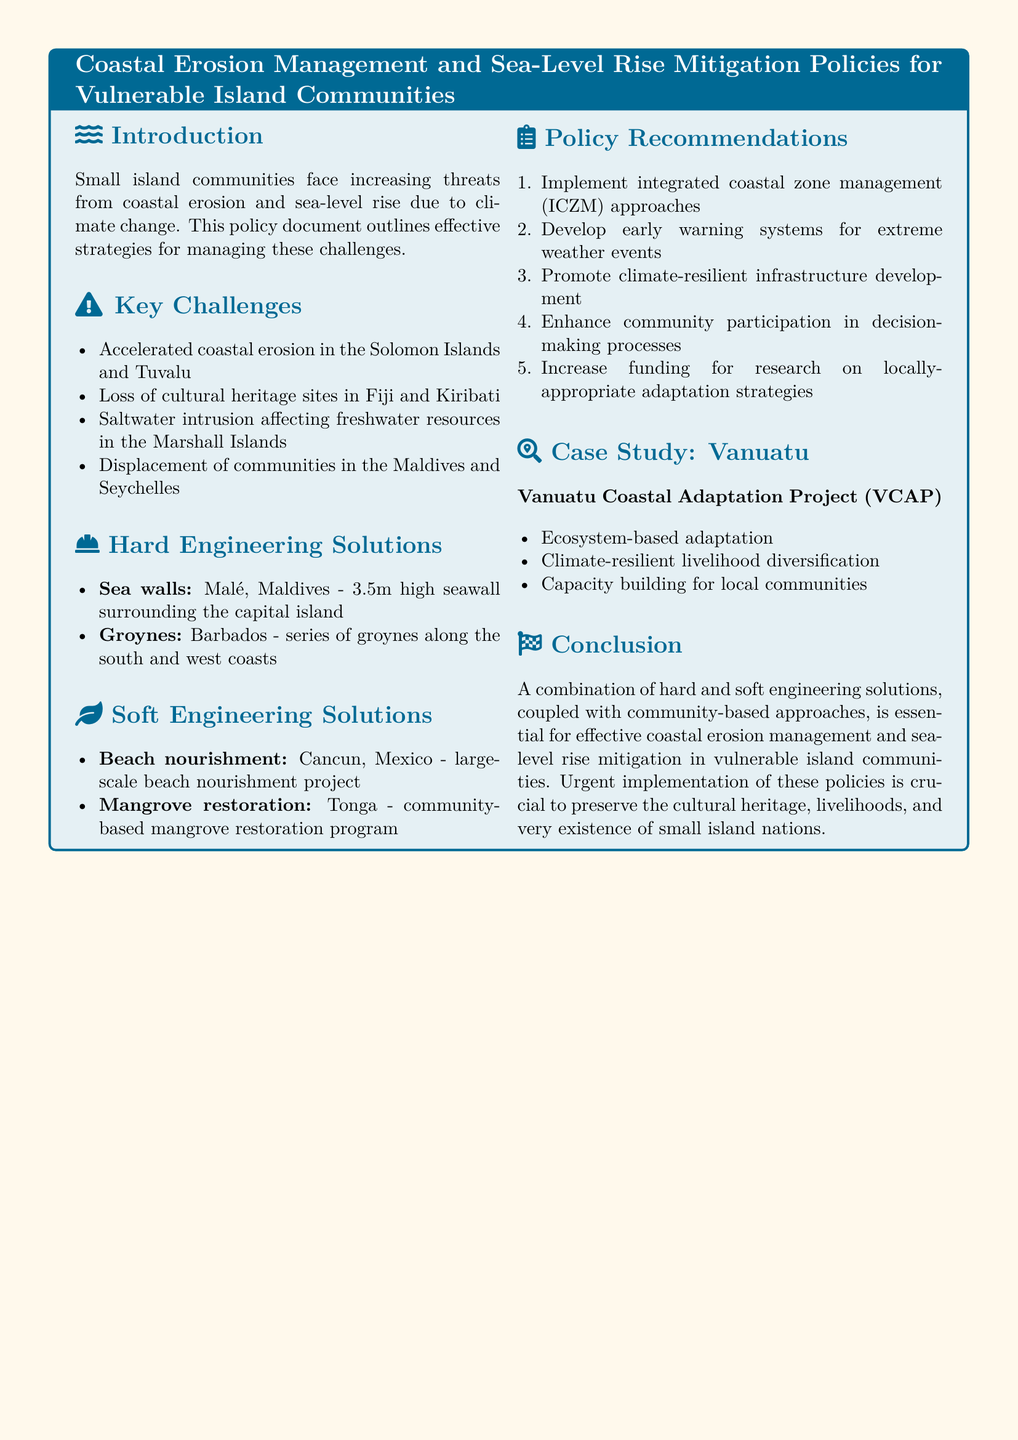What is the title of the document? The title of the document is found at the top section of the rendered policy document.
Answer: Coastal Erosion Management and Sea-Level Rise Mitigation Policies for Vulnerable Island Communities What is one key challenge mentioned regarding Fiji? The document lists challenges related to various island nations, including Fiji.
Answer: Loss of cultural heritage sites What hard engineering solution is implemented in the Maldives? The document outlines specific hard engineering solutions used in various locations, including the Maldives.
Answer: Sea walls What soft engineering solution is practiced in Tonga? The document mentions certain soft engineering solutions utilized in Tonga.
Answer: Mangrove restoration What is one policy recommendation provided in the document? The document includes a list of policy recommendations for managing coastal erosion and sea-level rise.
Answer: Implement integrated coastal zone management (ICZM) approaches What is one aim of the Vanuatu Coastal Adaptation Project? The case study section includes objectives for the Vanuatu Coastal Adaptation Project.
Answer: Ecosystem-based adaptation How many meters high is the seawall in Malé? The document provides specific measurements for the seawall mentioned.
Answer: 3.5m Which island community is facing displacement issues? The document identifies specific communities facing major risks, including displacement.
Answer: Maldives 